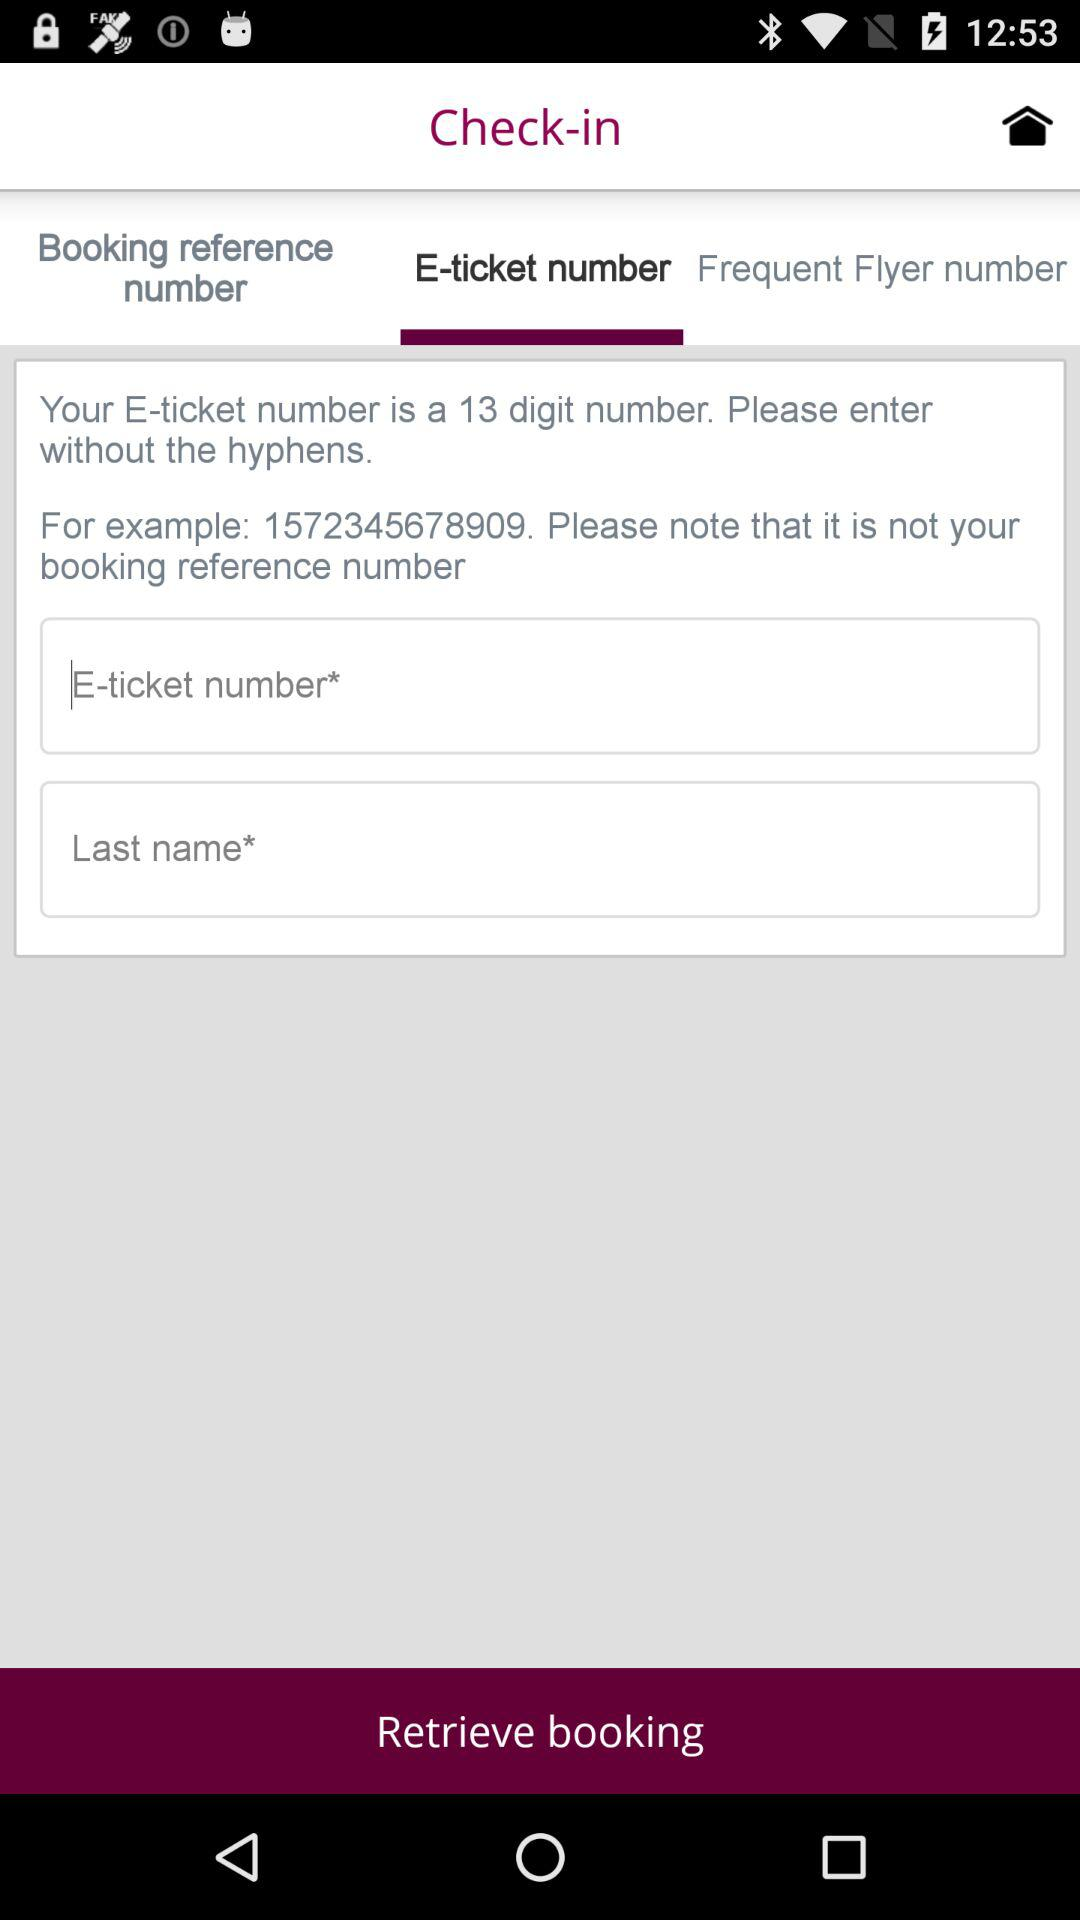What number is given in the example? The given number in the example is 1572345678909. 